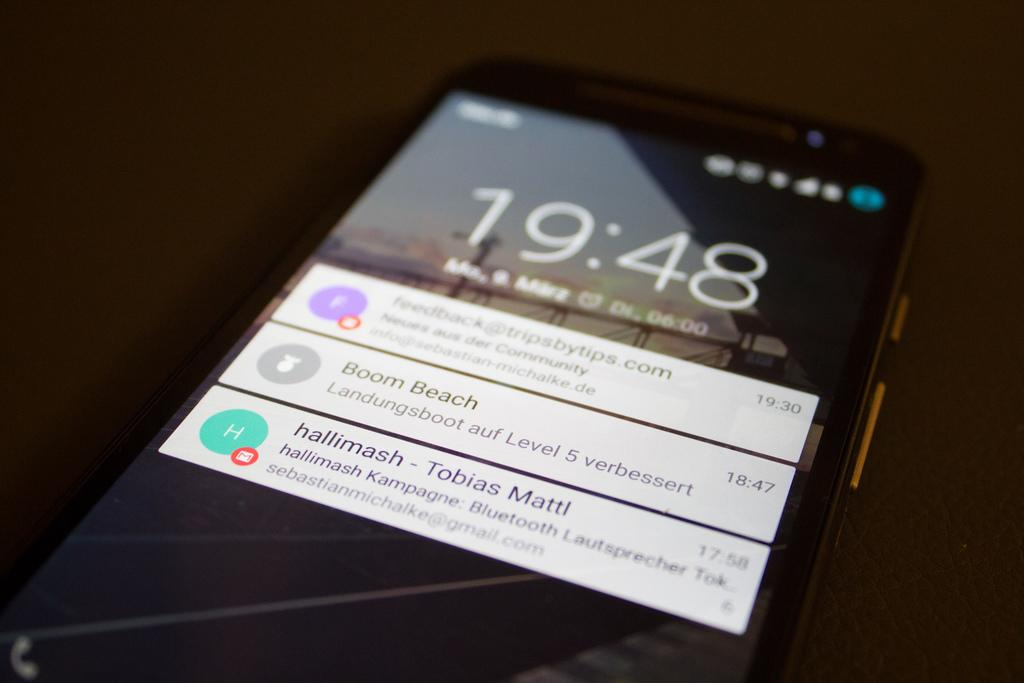Provide a one-sentence caption for the provided image. a phone with the time written on it that reads 19:48. 